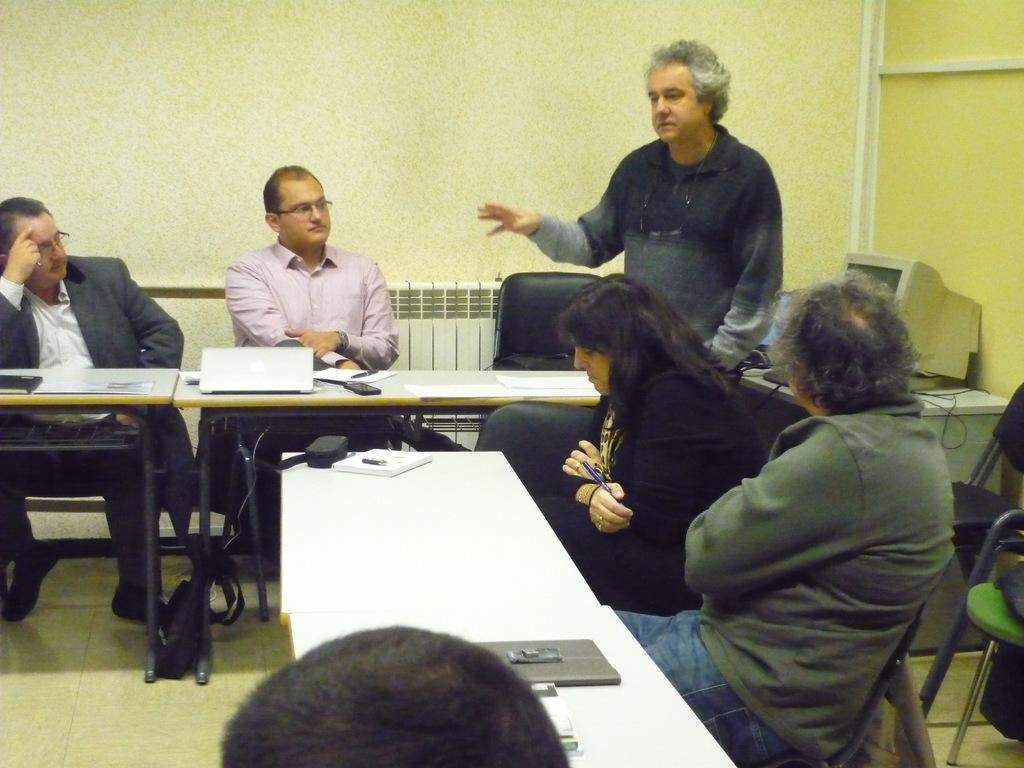What is the man in the image doing? The man is standing and speaking. How are the other people in the image positioned? There are four other people sitting and listening to him. What are the people sitting on or at? The people are sitting at tables. What electronic device is present on one of the tables? There is a laptop on one of the tables. What can be seen in the background of the image? There is a desktop in the background. What type of toothpaste is being used by the man in the image? There is no toothpaste present in the image; the man is standing and speaking. What metal object is being used by the people sitting at the tables? There is no specific metal object mentioned in the image; the people are sitting at tables and listening to the man. 